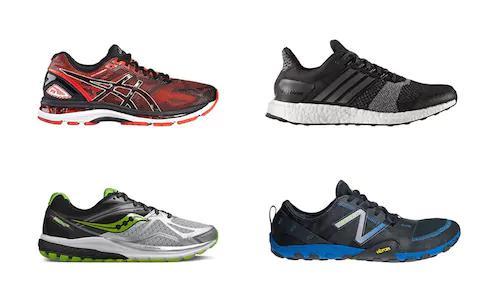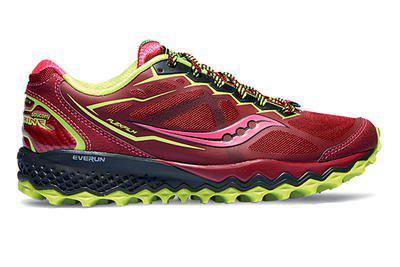The first image is the image on the left, the second image is the image on the right. Considering the images on both sides, is "The shoe in the image on the right has orange laces." valid? Answer yes or no. No. 